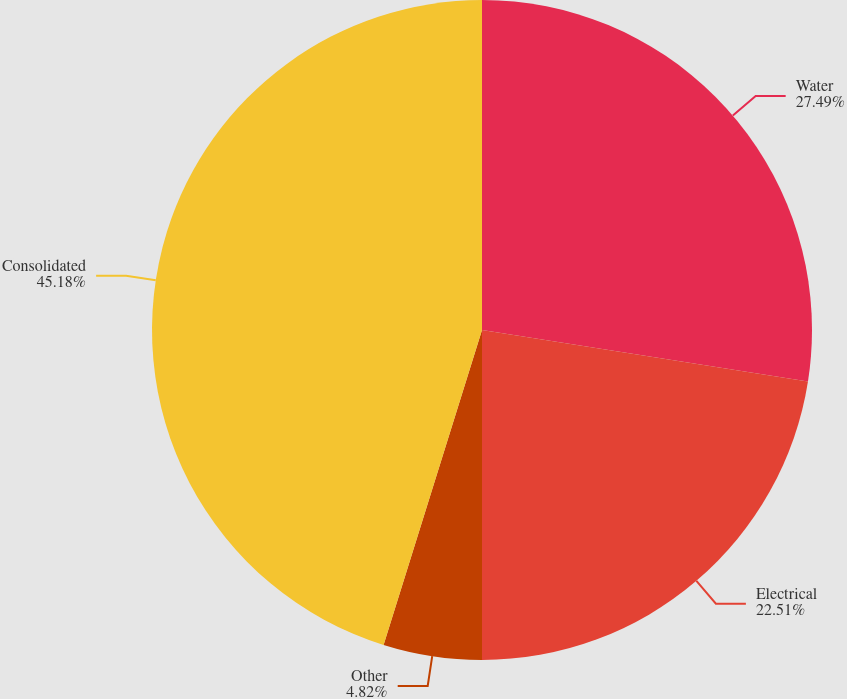Convert chart. <chart><loc_0><loc_0><loc_500><loc_500><pie_chart><fcel>Water<fcel>Electrical<fcel>Other<fcel>Consolidated<nl><fcel>27.49%<fcel>22.51%<fcel>4.82%<fcel>45.18%<nl></chart> 